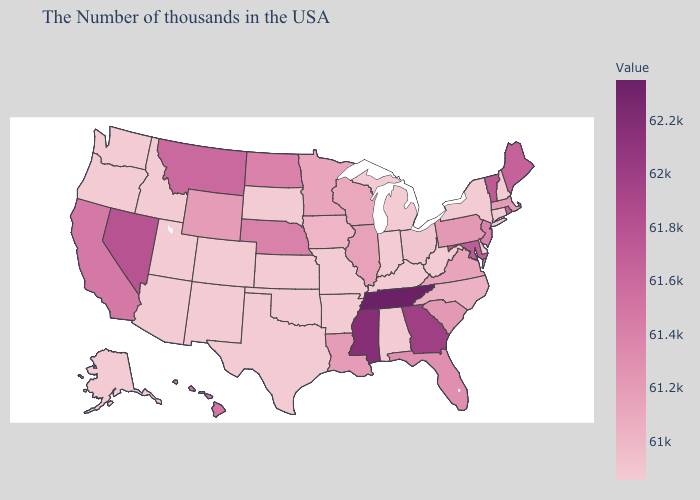Does Oklahoma have the highest value in the USA?
Be succinct. No. Does Illinois have the lowest value in the USA?
Answer briefly. No. Does Idaho have the lowest value in the USA?
Write a very short answer. Yes. Does the map have missing data?
Answer briefly. No. Does Maryland have a higher value than South Dakota?
Concise answer only. Yes. Among the states that border Pennsylvania , which have the lowest value?
Short answer required. New York, Delaware, West Virginia. Which states hav the highest value in the West?
Short answer required. Nevada. 